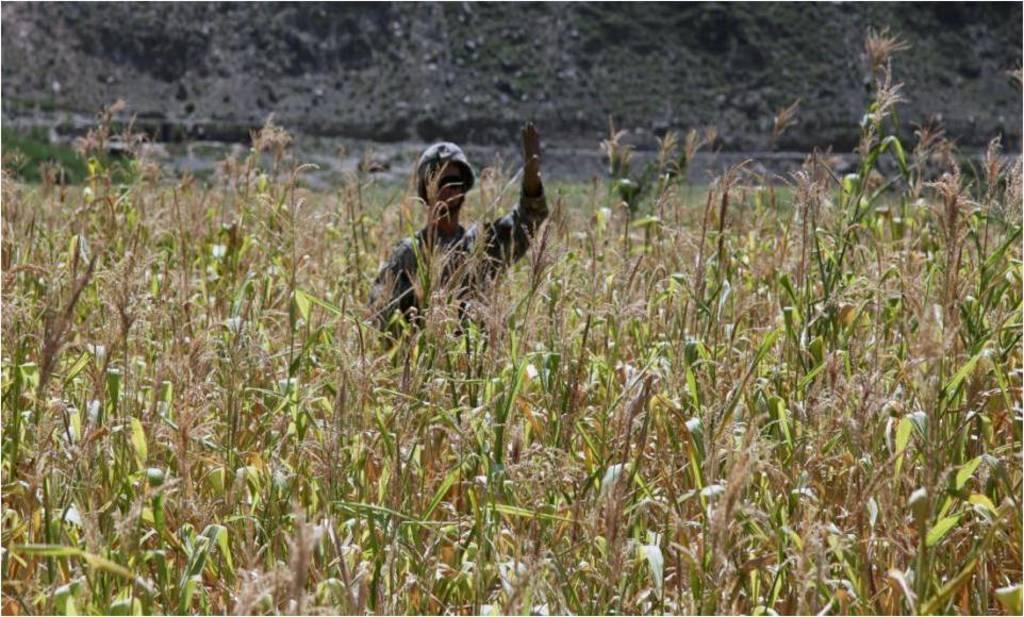Describe this image in one or two sentences. In this image we can see a person standing in the middle of the plants and in the background of the image there is mountain. 